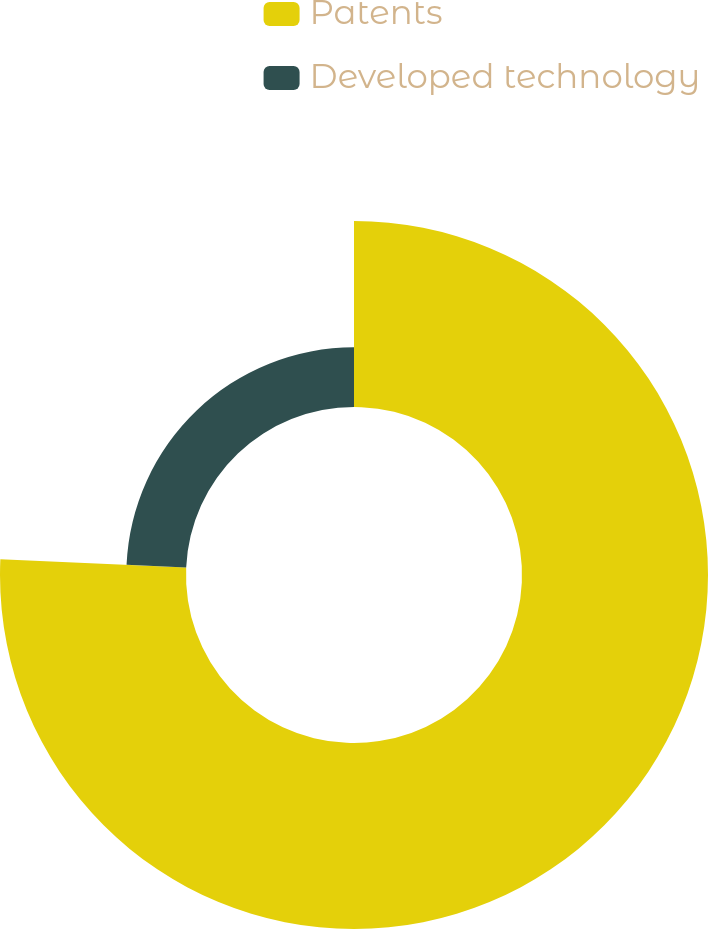Convert chart to OTSL. <chart><loc_0><loc_0><loc_500><loc_500><pie_chart><fcel>Patents<fcel>Developed technology<nl><fcel>75.71%<fcel>24.29%<nl></chart> 